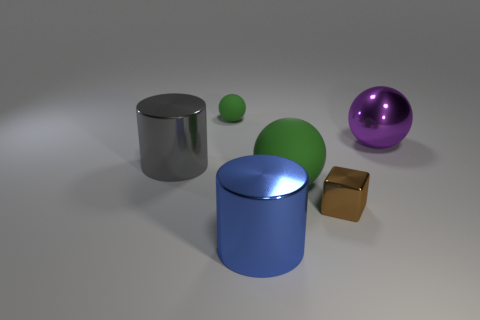Subtract all cylinders. How many objects are left? 4 Add 1 large metal spheres. How many objects exist? 7 Subtract all rubber things. Subtract all green cylinders. How many objects are left? 4 Add 1 big things. How many big things are left? 5 Add 5 big green metallic blocks. How many big green metallic blocks exist? 5 Subtract 1 brown cubes. How many objects are left? 5 